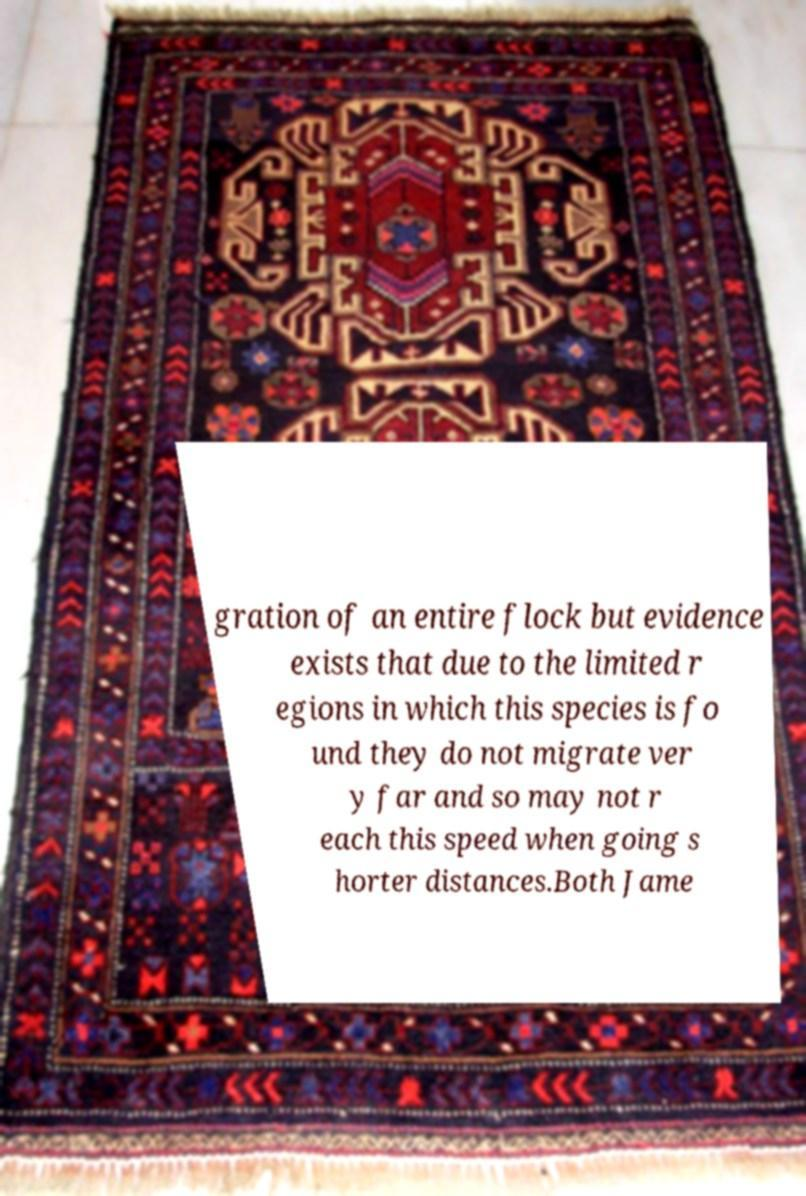For documentation purposes, I need the text within this image transcribed. Could you provide that? gration of an entire flock but evidence exists that due to the limited r egions in which this species is fo und they do not migrate ver y far and so may not r each this speed when going s horter distances.Both Jame 